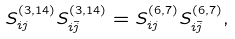<formula> <loc_0><loc_0><loc_500><loc_500>S _ { i j } ^ { ( 3 , 1 4 ) } S _ { i \bar { j } } ^ { ( 3 , 1 4 ) } = S _ { i j } ^ { ( 6 , 7 ) } S _ { i \bar { j } } ^ { ( 6 , 7 ) } ,</formula> 